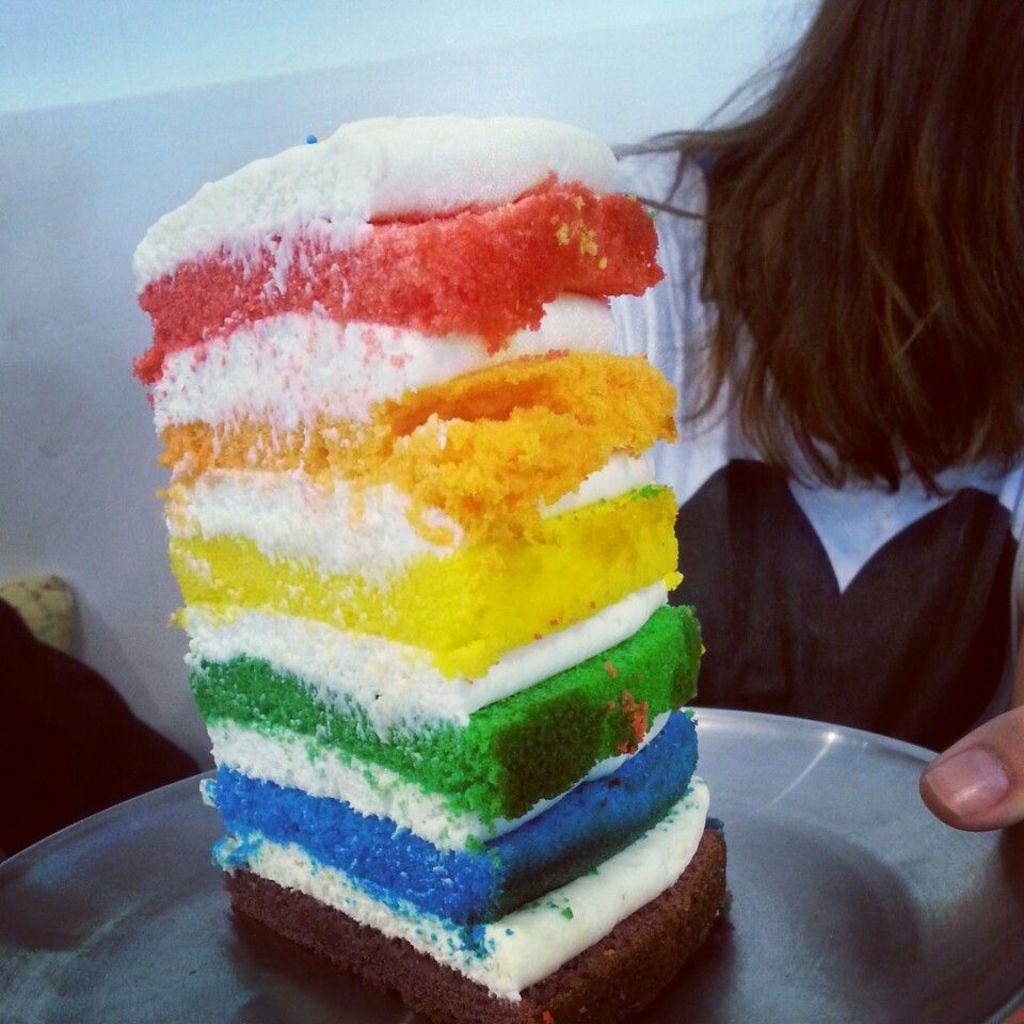What is the main subject of the image? There is a person in the image. What is the person holding in the image? The person is holding a plate. What is on the plate that the person is holding? The plate contains a piece of cake with cream on it. What can be seen in the background of the image? There is a wall in the background of the image. What type of base is supporting the doll in the image? There is no doll present in the image, so there is no base supporting a doll. What is the occupation of the secretary in the image? There is no secretary present in the image. 